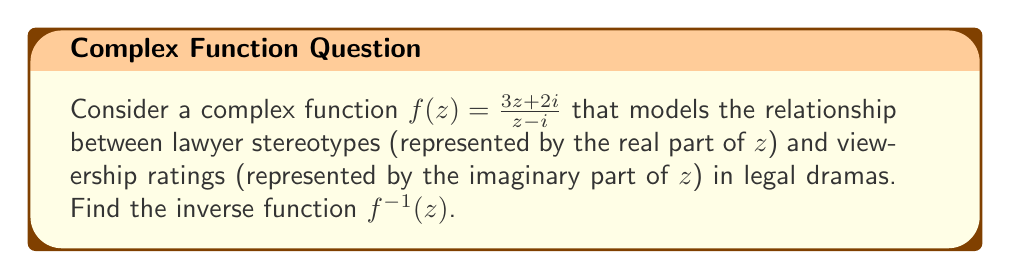Provide a solution to this math problem. To find the inverse of the complex function $f(z) = \frac{3z + 2i}{z - i}$, we'll follow these steps:

1) Let $w = f(z) = \frac{3z + 2i}{z - i}$

2) Multiply both sides by $(z - i)$:
   $w(z - i) = 3z + 2i$

3) Expand:
   $wz - wi = 3z + 2i$

4) Rearrange terms:
   $wz - 3z = wi + 2i$

5) Factor out $z$:
   $z(w - 3) = i(w + 2)$

6) Solve for $z$:
   $z = \frac{i(w + 2)}{w - 3}$

7) This gives us the inverse function. To express it in the standard form $f^{-1}(z)$, replace $w$ with $z$:
   $f^{-1}(z) = \frac{i(z + 2)}{z - 3}$

8) Simplify by multiplying numerator and denominator by $-i$:
   $f^{-1}(z) = \frac{z + 2}{i(z - 3)} = \frac{z + 2}{3 - z} \cdot \frac{-i}{-i} = \frac{(z + 2)(-i)}{(3 - z)(-i)} = \frac{-i(z + 2)}{3 - z}$

Therefore, the inverse function is $f^{-1}(z) = \frac{-i(z + 2)}{3 - z}$.
Answer: $f^{-1}(z) = \frac{-i(z + 2)}{3 - z}$ 